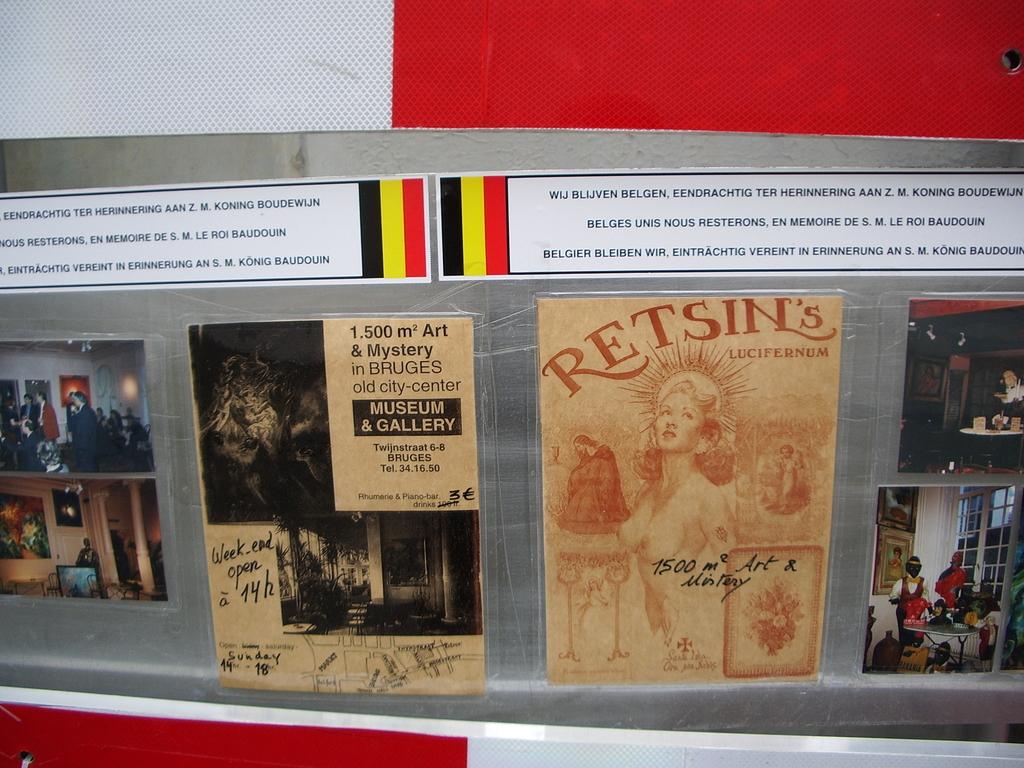Where is the museum and gallery according to the sign?
Keep it short and to the point. Bruges. 